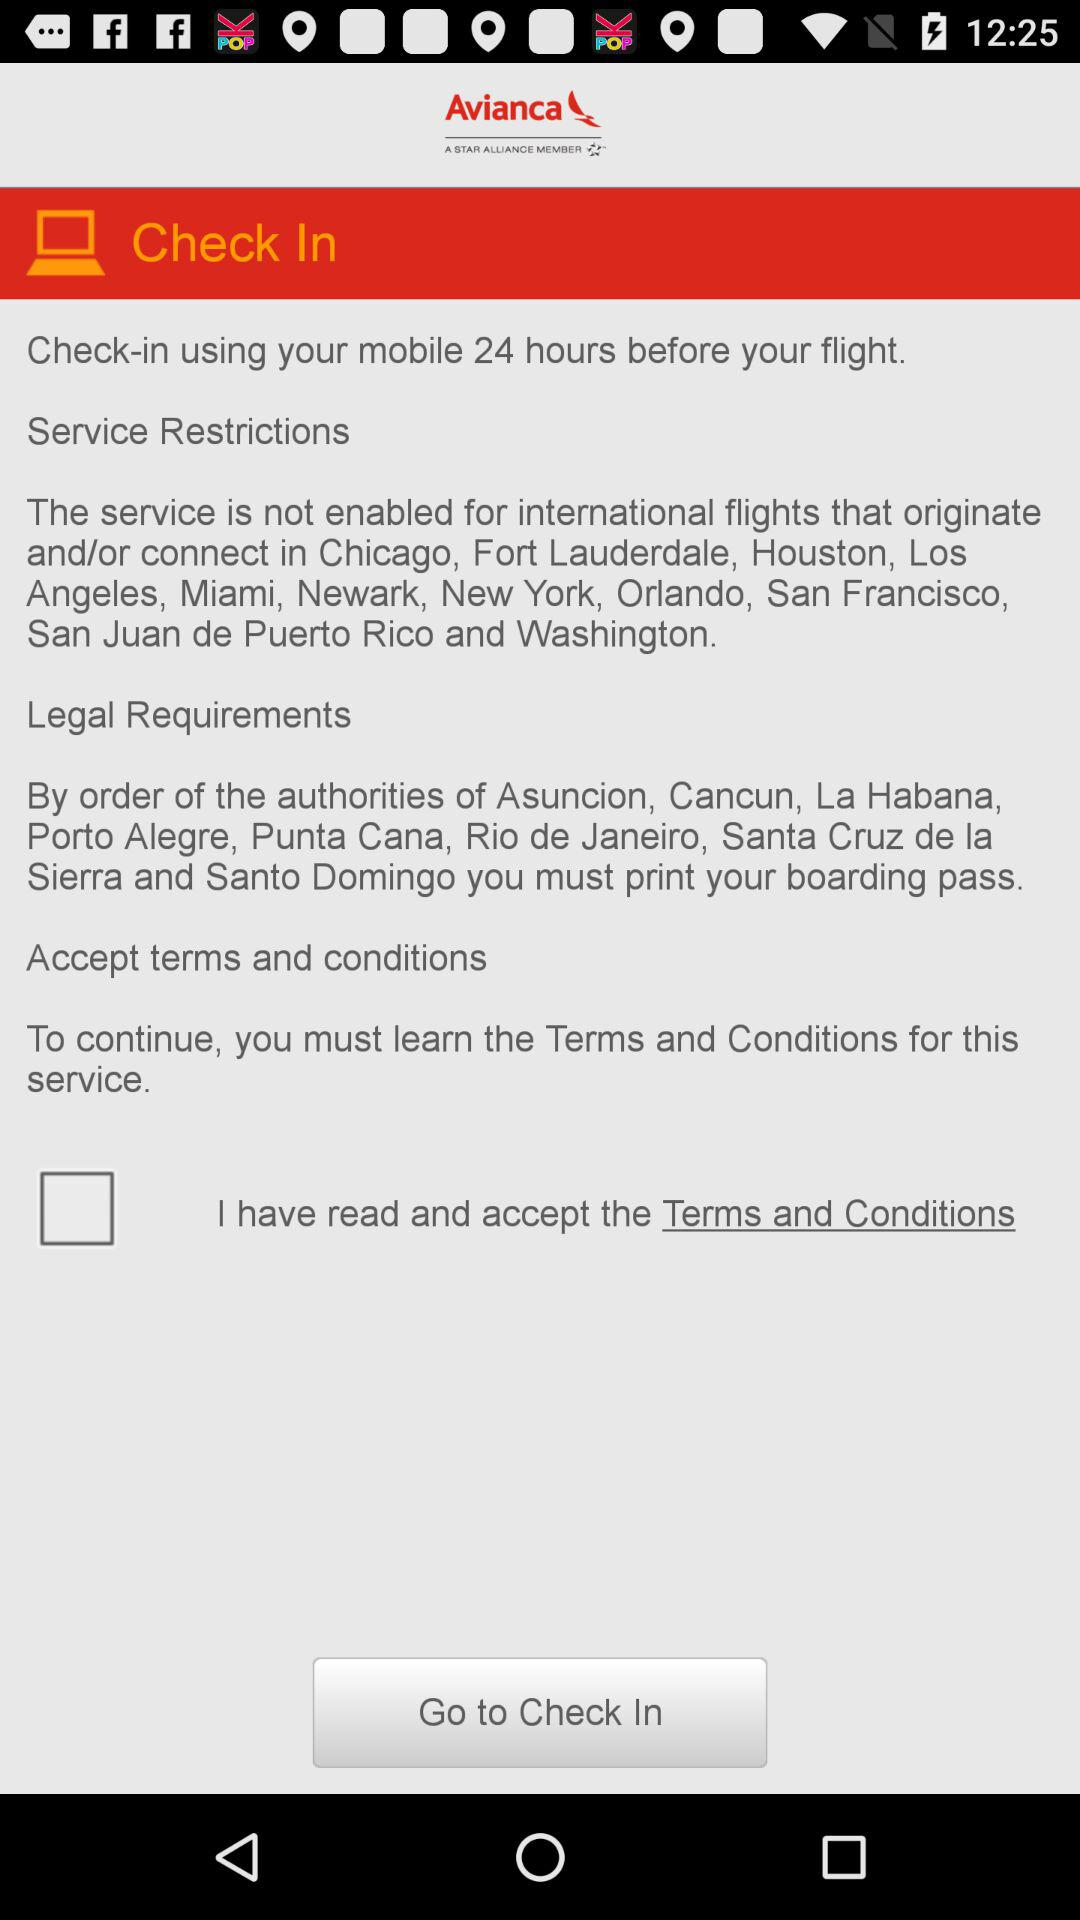What is the application name? The application name is "Avianca". 